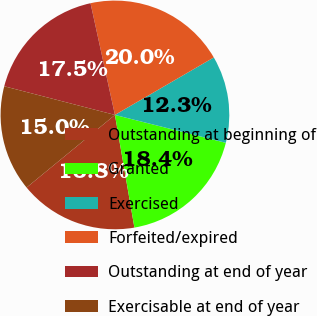Convert chart to OTSL. <chart><loc_0><loc_0><loc_500><loc_500><pie_chart><fcel>Outstanding at beginning of<fcel>Granted<fcel>Exercised<fcel>Forfeited/expired<fcel>Outstanding at end of year<fcel>Exercisable at end of year<nl><fcel>16.77%<fcel>18.35%<fcel>12.3%<fcel>20.04%<fcel>17.54%<fcel>14.98%<nl></chart> 